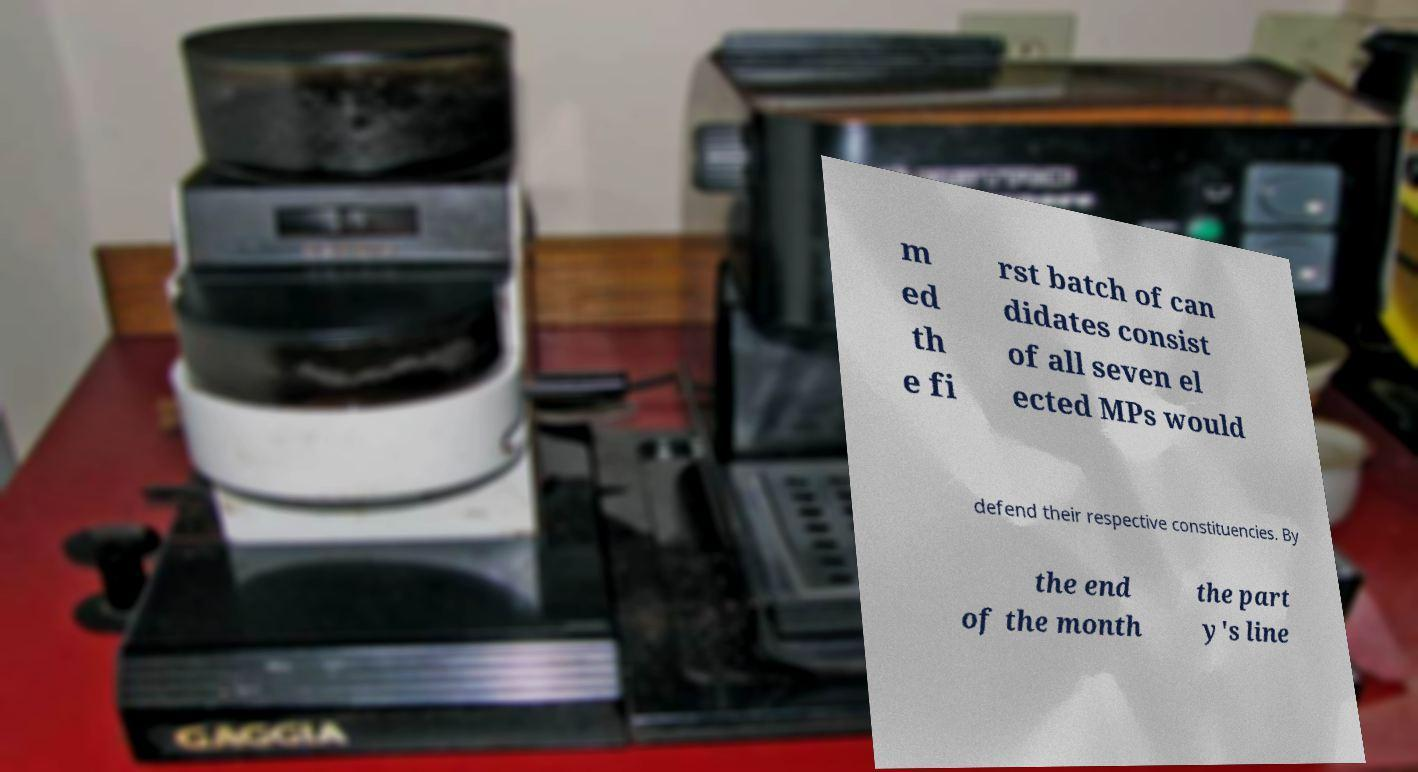What messages or text are displayed in this image? I need them in a readable, typed format. m ed th e fi rst batch of can didates consist of all seven el ected MPs would defend their respective constituencies. By the end of the month the part y's line 